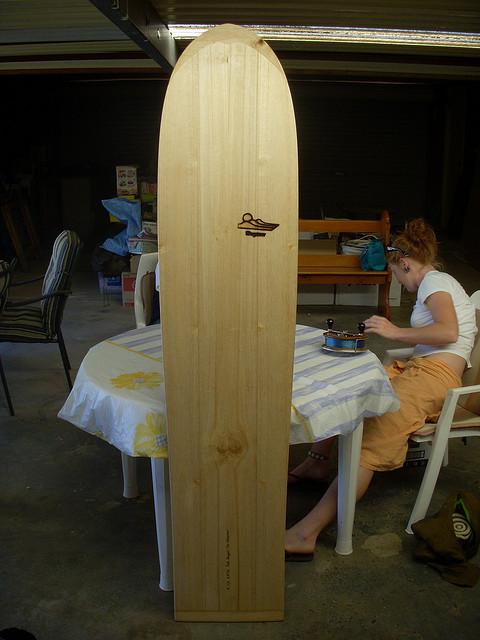What color are the woman's pants?
Answer briefly. Yellow. Do all the chairs fold?
Concise answer only. No. Where are the yellow pants?
Give a very brief answer. On woman. Who are these chairs made to fit?
Write a very short answer. Adults. Is the woman wearing shoes?
Answer briefly. No. 